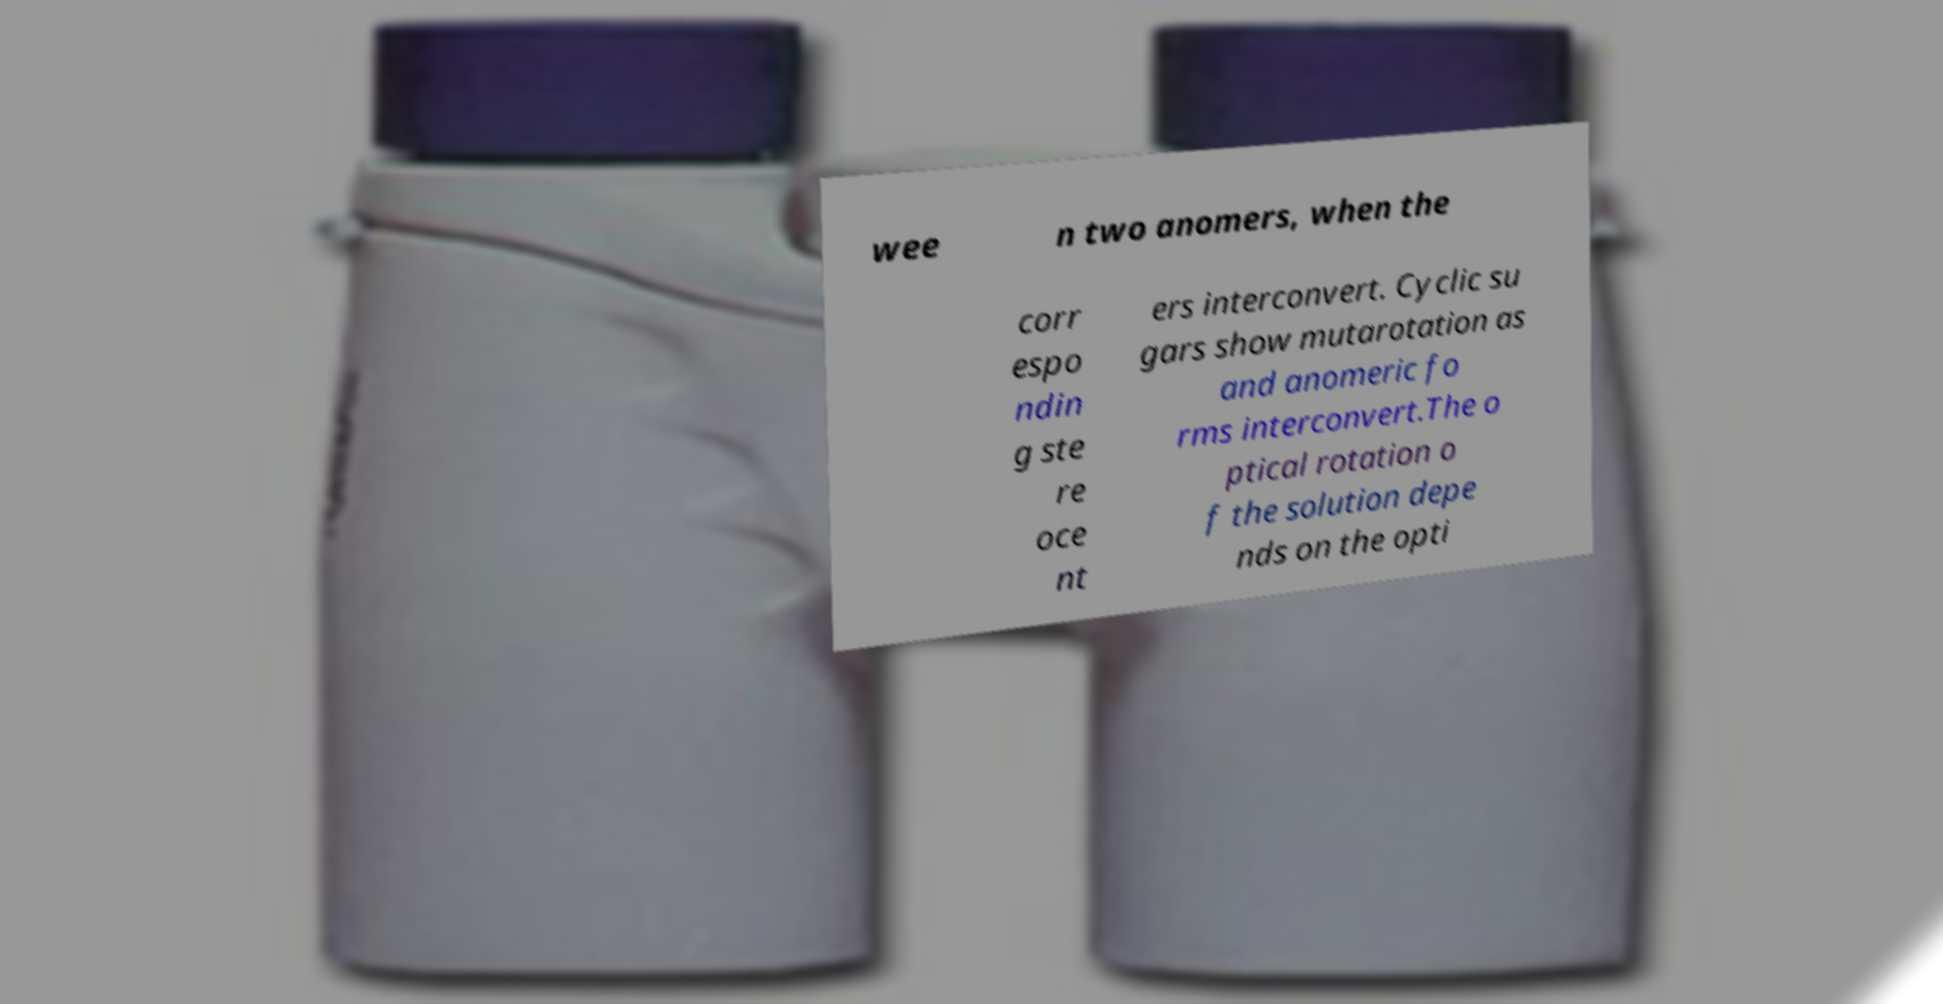Please read and relay the text visible in this image. What does it say? wee n two anomers, when the corr espo ndin g ste re oce nt ers interconvert. Cyclic su gars show mutarotation as and anomeric fo rms interconvert.The o ptical rotation o f the solution depe nds on the opti 